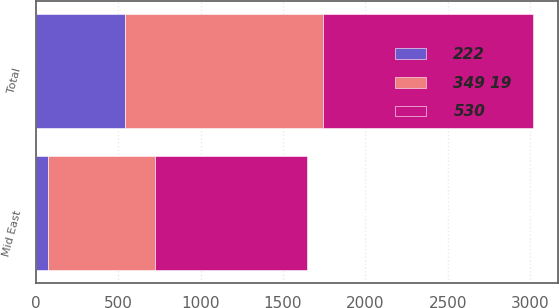Convert chart. <chart><loc_0><loc_0><loc_500><loc_500><stacked_bar_chart><ecel><fcel>Mid East<fcel>Total<nl><fcel>349 19<fcel>649<fcel>1200<nl><fcel>530<fcel>923<fcel>1274<nl><fcel>222<fcel>72<fcel>542<nl></chart> 